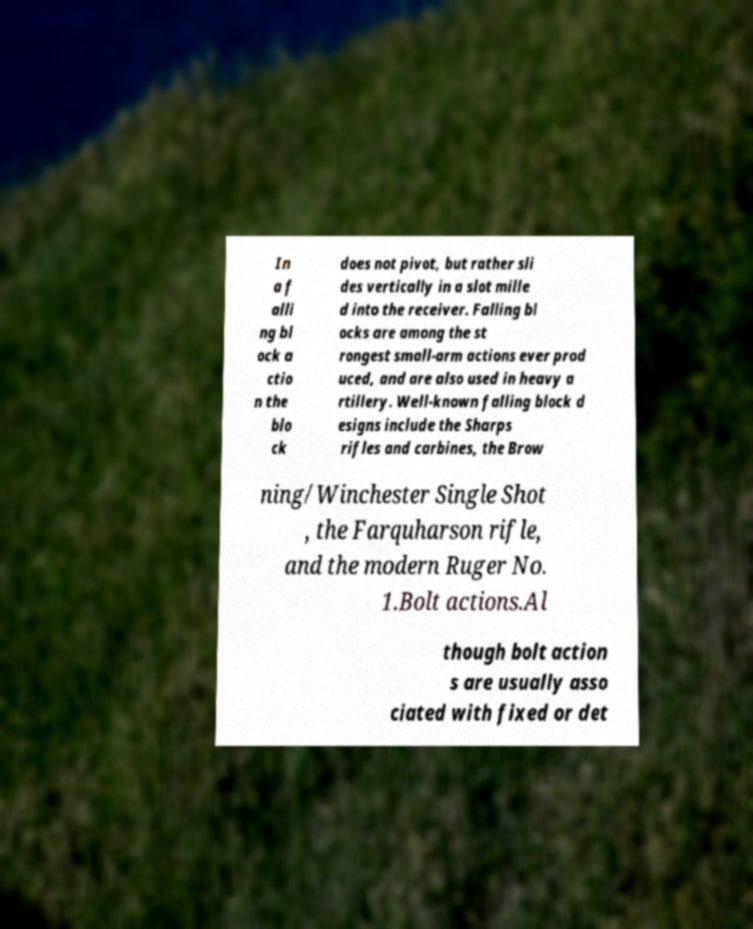Could you assist in decoding the text presented in this image and type it out clearly? In a f alli ng bl ock a ctio n the blo ck does not pivot, but rather sli des vertically in a slot mille d into the receiver. Falling bl ocks are among the st rongest small-arm actions ever prod uced, and are also used in heavy a rtillery. Well-known falling block d esigns include the Sharps rifles and carbines, the Brow ning/Winchester Single Shot , the Farquharson rifle, and the modern Ruger No. 1.Bolt actions.Al though bolt action s are usually asso ciated with fixed or det 